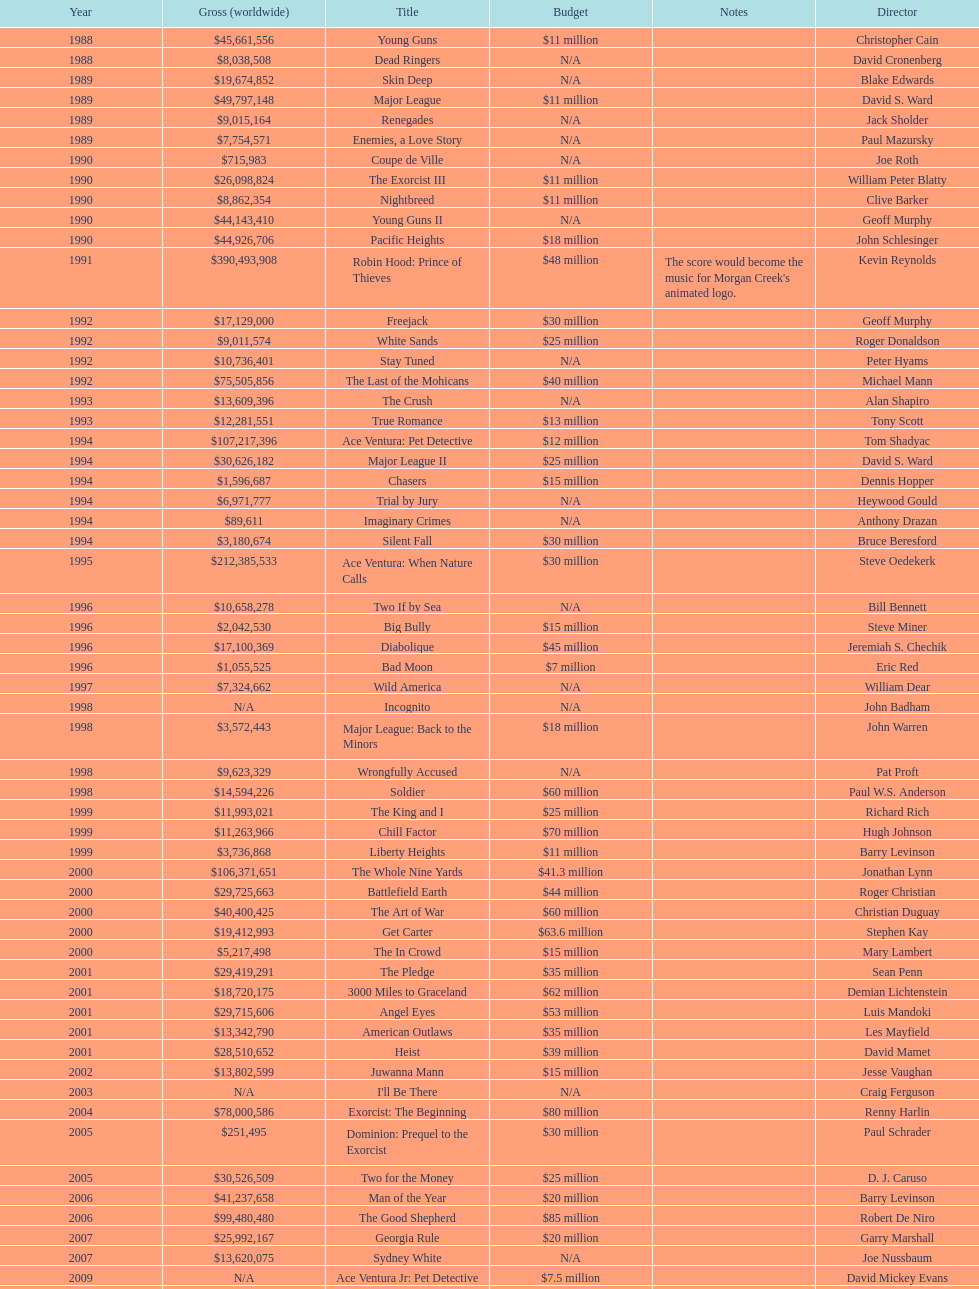What movie was made immediately before the pledge? The In Crowd. Would you mind parsing the complete table? {'header': ['Year', 'Gross (worldwide)', 'Title', 'Budget', 'Notes', 'Director'], 'rows': [['1988', '$45,661,556', 'Young Guns', '$11 million', '', 'Christopher Cain'], ['1988', '$8,038,508', 'Dead Ringers', 'N/A', '', 'David Cronenberg'], ['1989', '$19,674,852', 'Skin Deep', 'N/A', '', 'Blake Edwards'], ['1989', '$49,797,148', 'Major League', '$11 million', '', 'David S. Ward'], ['1989', '$9,015,164', 'Renegades', 'N/A', '', 'Jack Sholder'], ['1989', '$7,754,571', 'Enemies, a Love Story', 'N/A', '', 'Paul Mazursky'], ['1990', '$715,983', 'Coupe de Ville', 'N/A', '', 'Joe Roth'], ['1990', '$26,098,824', 'The Exorcist III', '$11 million', '', 'William Peter Blatty'], ['1990', '$8,862,354', 'Nightbreed', '$11 million', '', 'Clive Barker'], ['1990', '$44,143,410', 'Young Guns II', 'N/A', '', 'Geoff Murphy'], ['1990', '$44,926,706', 'Pacific Heights', '$18 million', '', 'John Schlesinger'], ['1991', '$390,493,908', 'Robin Hood: Prince of Thieves', '$48 million', "The score would become the music for Morgan Creek's animated logo.", 'Kevin Reynolds'], ['1992', '$17,129,000', 'Freejack', '$30 million', '', 'Geoff Murphy'], ['1992', '$9,011,574', 'White Sands', '$25 million', '', 'Roger Donaldson'], ['1992', '$10,736,401', 'Stay Tuned', 'N/A', '', 'Peter Hyams'], ['1992', '$75,505,856', 'The Last of the Mohicans', '$40 million', '', 'Michael Mann'], ['1993', '$13,609,396', 'The Crush', 'N/A', '', 'Alan Shapiro'], ['1993', '$12,281,551', 'True Romance', '$13 million', '', 'Tony Scott'], ['1994', '$107,217,396', 'Ace Ventura: Pet Detective', '$12 million', '', 'Tom Shadyac'], ['1994', '$30,626,182', 'Major League II', '$25 million', '', 'David S. Ward'], ['1994', '$1,596,687', 'Chasers', '$15 million', '', 'Dennis Hopper'], ['1994', '$6,971,777', 'Trial by Jury', 'N/A', '', 'Heywood Gould'], ['1994', '$89,611', 'Imaginary Crimes', 'N/A', '', 'Anthony Drazan'], ['1994', '$3,180,674', 'Silent Fall', '$30 million', '', 'Bruce Beresford'], ['1995', '$212,385,533', 'Ace Ventura: When Nature Calls', '$30 million', '', 'Steve Oedekerk'], ['1996', '$10,658,278', 'Two If by Sea', 'N/A', '', 'Bill Bennett'], ['1996', '$2,042,530', 'Big Bully', '$15 million', '', 'Steve Miner'], ['1996', '$17,100,369', 'Diabolique', '$45 million', '', 'Jeremiah S. Chechik'], ['1996', '$1,055,525', 'Bad Moon', '$7 million', '', 'Eric Red'], ['1997', '$7,324,662', 'Wild America', 'N/A', '', 'William Dear'], ['1998', 'N/A', 'Incognito', 'N/A', '', 'John Badham'], ['1998', '$3,572,443', 'Major League: Back to the Minors', '$18 million', '', 'John Warren'], ['1998', '$9,623,329', 'Wrongfully Accused', 'N/A', '', 'Pat Proft'], ['1998', '$14,594,226', 'Soldier', '$60 million', '', 'Paul W.S. Anderson'], ['1999', '$11,993,021', 'The King and I', '$25 million', '', 'Richard Rich'], ['1999', '$11,263,966', 'Chill Factor', '$70 million', '', 'Hugh Johnson'], ['1999', '$3,736,868', 'Liberty Heights', '$11 million', '', 'Barry Levinson'], ['2000', '$106,371,651', 'The Whole Nine Yards', '$41.3 million', '', 'Jonathan Lynn'], ['2000', '$29,725,663', 'Battlefield Earth', '$44 million', '', 'Roger Christian'], ['2000', '$40,400,425', 'The Art of War', '$60 million', '', 'Christian Duguay'], ['2000', '$19,412,993', 'Get Carter', '$63.6 million', '', 'Stephen Kay'], ['2000', '$5,217,498', 'The In Crowd', '$15 million', '', 'Mary Lambert'], ['2001', '$29,419,291', 'The Pledge', '$35 million', '', 'Sean Penn'], ['2001', '$18,720,175', '3000 Miles to Graceland', '$62 million', '', 'Demian Lichtenstein'], ['2001', '$29,715,606', 'Angel Eyes', '$53 million', '', 'Luis Mandoki'], ['2001', '$13,342,790', 'American Outlaws', '$35 million', '', 'Les Mayfield'], ['2001', '$28,510,652', 'Heist', '$39 million', '', 'David Mamet'], ['2002', '$13,802,599', 'Juwanna Mann', '$15 million', '', 'Jesse Vaughan'], ['2003', 'N/A', "I'll Be There", 'N/A', '', 'Craig Ferguson'], ['2004', '$78,000,586', 'Exorcist: The Beginning', '$80 million', '', 'Renny Harlin'], ['2005', '$251,495', 'Dominion: Prequel to the Exorcist', '$30 million', '', 'Paul Schrader'], ['2005', '$30,526,509', 'Two for the Money', '$25 million', '', 'D. J. Caruso'], ['2006', '$41,237,658', 'Man of the Year', '$20 million', '', 'Barry Levinson'], ['2006', '$99,480,480', 'The Good Shepherd', '$85 million', '', 'Robert De Niro'], ['2007', '$25,992,167', 'Georgia Rule', '$20 million', '', 'Garry Marshall'], ['2007', '$13,620,075', 'Sydney White', 'N/A', '', 'Joe Nussbaum'], ['2009', 'N/A', 'Ace Ventura Jr: Pet Detective', '$7.5 million', '', 'David Mickey Evans'], ['2011', '$38,502,340', 'Dream House', '$50 million', '', 'Jim Sheridan'], ['2011', '$27,428,670', 'The Thing', '$38 million', '', 'Matthijs van Heijningen Jr.'], ['2014', '', 'Tupac', '$45 million', '', 'Antoine Fuqua']]} 